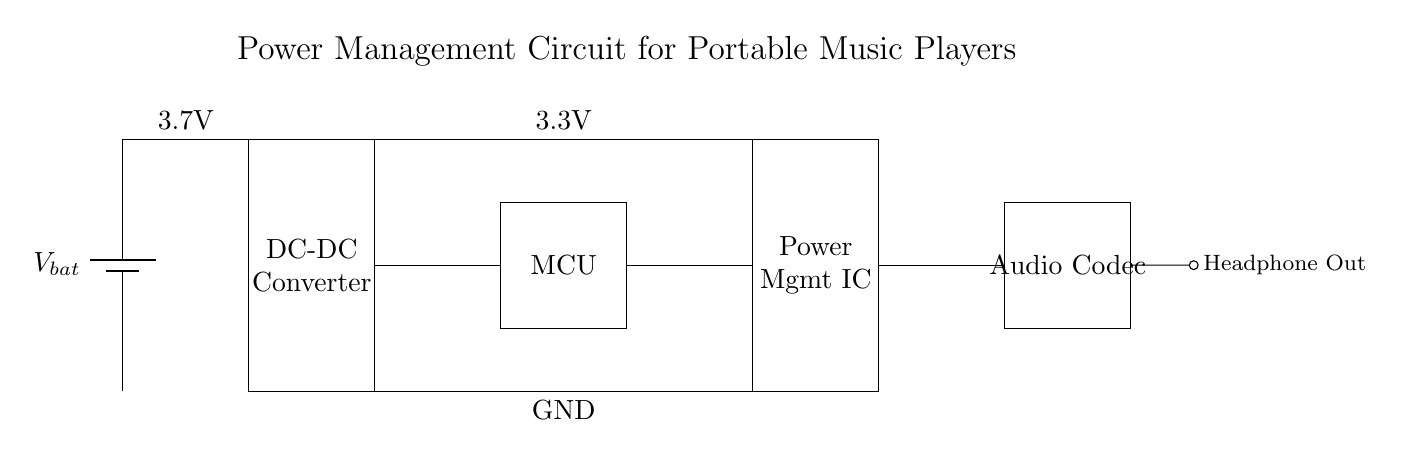What is the primary function of the DC-DC converter? The primary function of the DC-DC converter is to step up or step down the voltage from the battery to a level suitable for the microcontroller and other components in the circuit. This ensures that each component receives the appropriate voltage for operation.
Answer: Step up or step down voltage What voltage does the battery provide? The battery provides a voltage of 3.7 volts, as indicated by the label next to the battery symbol in the circuit diagram.
Answer: 3.7 volts Which component is responsible for managing power distribution? The component responsible for managing power distribution in the circuit is the Power Management Integrated Circuit (IC), which regulates and distributes power to various parts of the circuit.
Answer: Power Management IC What is the output voltage from the microcontroller? The output voltage from the microcontroller is 3.3 volts, which is the voltage level required for it to operate correctly according to the circuit.
Answer: 3.3 volts How is the audio output connected in the circuit? The audio output is connected via a short wire leading out from the audio codec, which indicates that the signal is sent to the headphones. This outlines how the audio is delivered to the user.
Answer: Through headphone out What component directly connects to the audio codec? The component that directly connects to the audio codec is the Power Management IC, ensuring it gets the necessary power to function and send audio signals through the headphone output.
Answer: Power Management IC Which two components interact to provide the necessary voltage to the microcontroller? The battery and the DC-DC converter interact to provide the necessary voltage to the microcontroller. The battery supplies power, while the DC-DC converter can modify the voltage level to 3.3 volts.
Answer: Battery and DC-DC Converter 